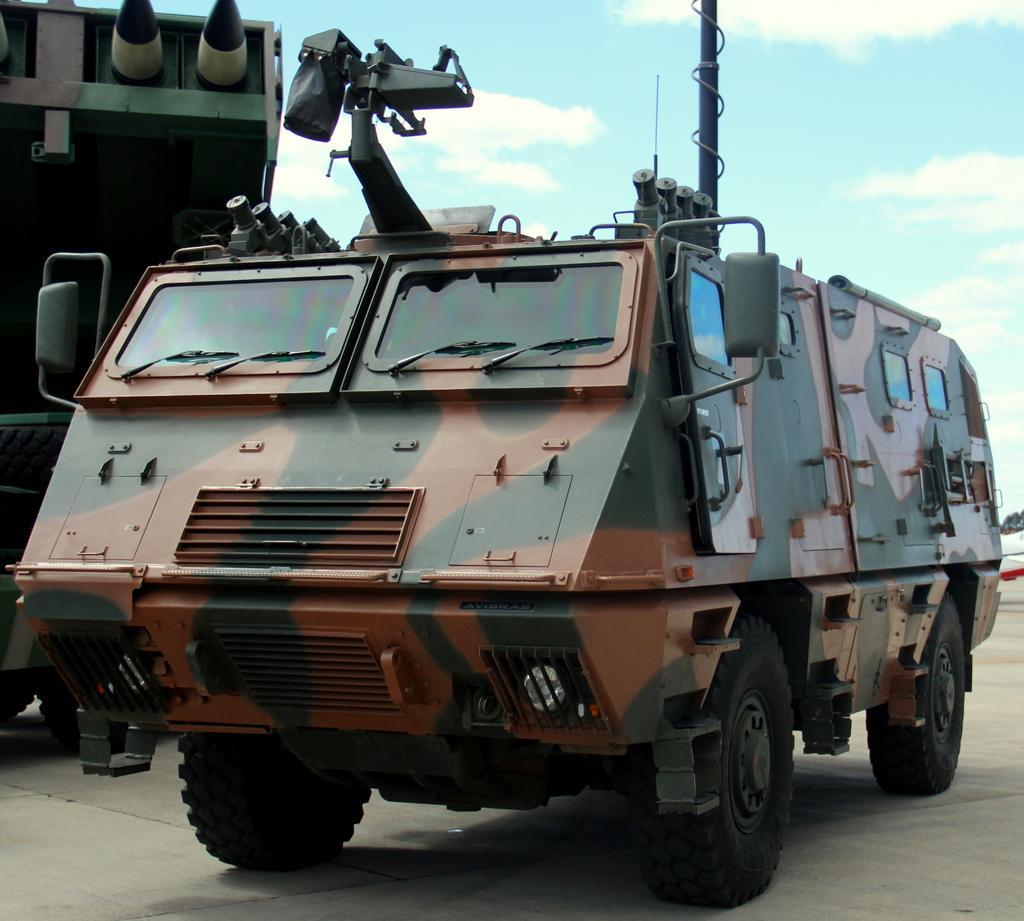In one or two sentences, can you explain what this image depicts? In this picture we can see a vehicle on the ground, some objects and in the background we can see the sky with clouds. 